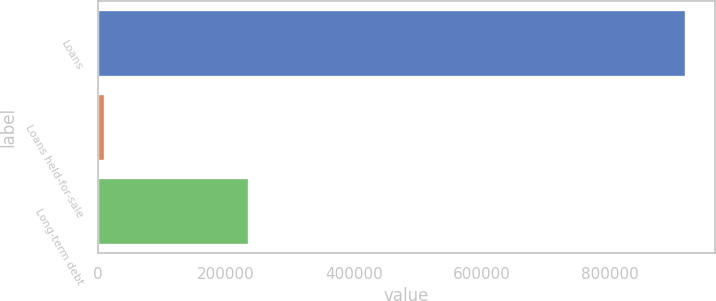<chart> <loc_0><loc_0><loc_500><loc_500><bar_chart><fcel>Loans<fcel>Loans held-for-sale<fcel>Long-term debt<nl><fcel>918162<fcel>11430<fcel>236989<nl></chart> 